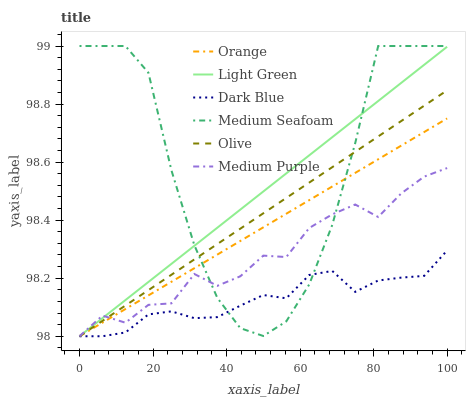Does Medium Purple have the minimum area under the curve?
Answer yes or no. No. Does Medium Purple have the maximum area under the curve?
Answer yes or no. No. Is Medium Purple the smoothest?
Answer yes or no. No. Is Medium Purple the roughest?
Answer yes or no. No. Does Medium Seafoam have the lowest value?
Answer yes or no. No. Does Medium Purple have the highest value?
Answer yes or no. No. 